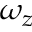Convert formula to latex. <formula><loc_0><loc_0><loc_500><loc_500>\omega _ { z }</formula> 